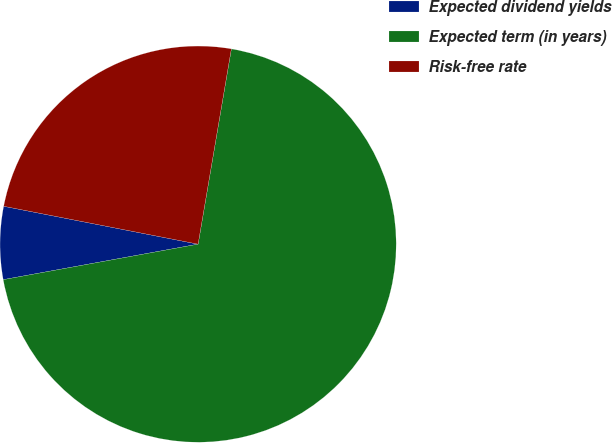Convert chart to OTSL. <chart><loc_0><loc_0><loc_500><loc_500><pie_chart><fcel>Expected dividend yields<fcel>Expected term (in years)<fcel>Risk-free rate<nl><fcel>5.93%<fcel>69.44%<fcel>24.62%<nl></chart> 